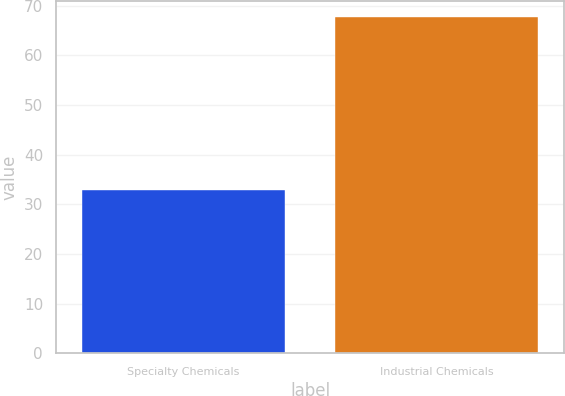<chart> <loc_0><loc_0><loc_500><loc_500><bar_chart><fcel>Specialty Chemicals<fcel>Industrial Chemicals<nl><fcel>32.9<fcel>67.6<nl></chart> 